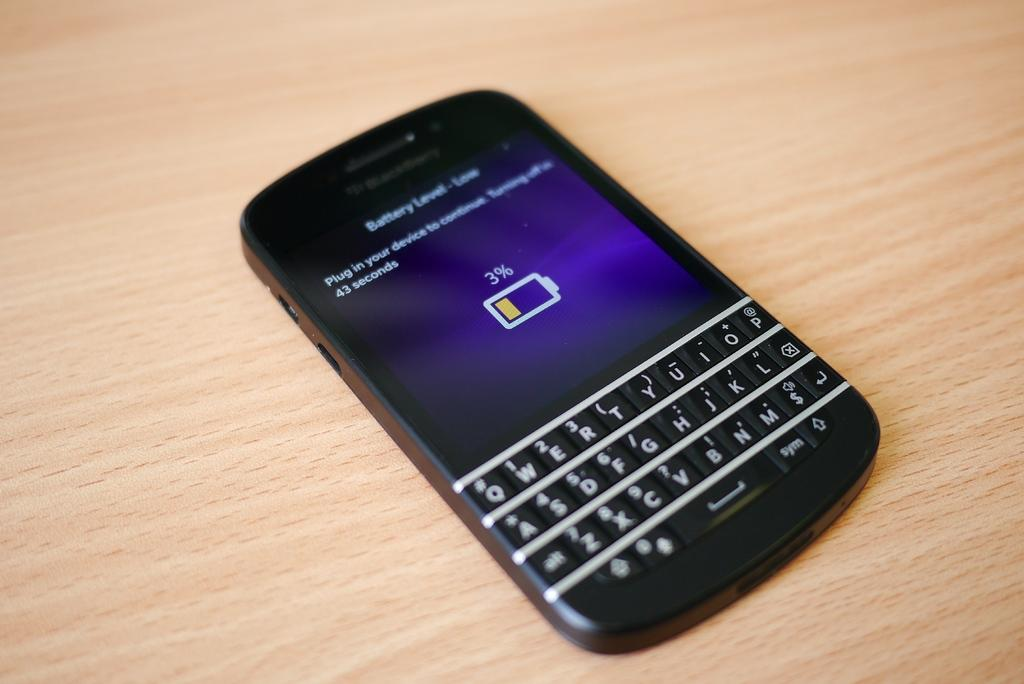<image>
Give a short and clear explanation of the subsequent image. Black phone showing the current battery life is 3%. 